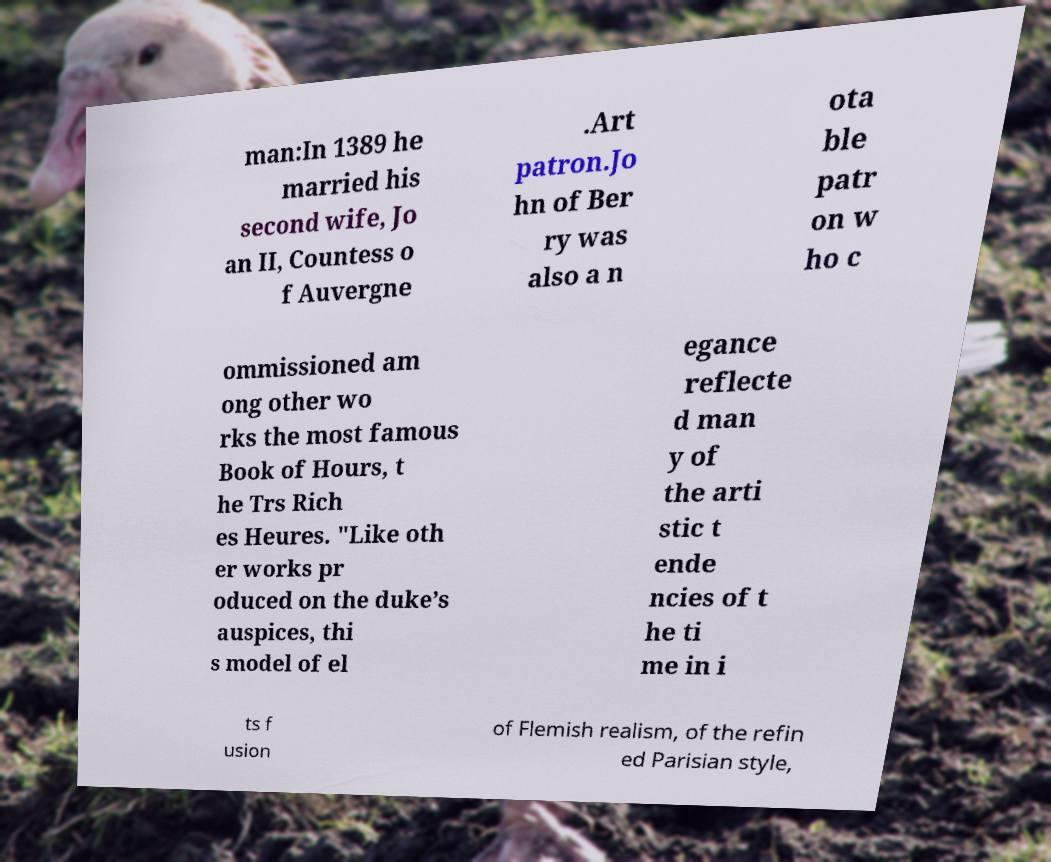What messages or text are displayed in this image? I need them in a readable, typed format. man:In 1389 he married his second wife, Jo an II, Countess o f Auvergne .Art patron.Jo hn of Ber ry was also a n ota ble patr on w ho c ommissioned am ong other wo rks the most famous Book of Hours, t he Trs Rich es Heures. "Like oth er works pr oduced on the duke’s auspices, thi s model of el egance reflecte d man y of the arti stic t ende ncies of t he ti me in i ts f usion of Flemish realism, of the refin ed Parisian style, 